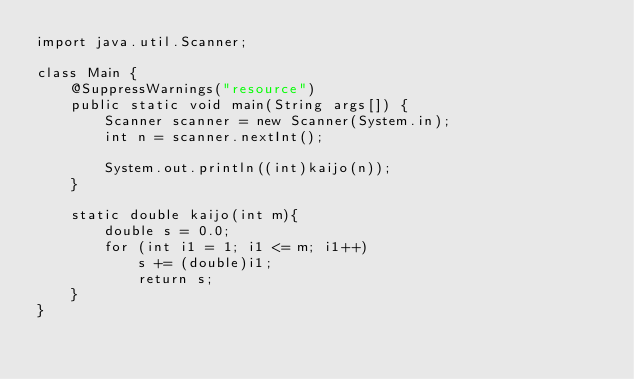<code> <loc_0><loc_0><loc_500><loc_500><_Java_>import java.util.Scanner;

class Main {
	@SuppressWarnings("resource")
	public static void main(String args[]) {
		Scanner scanner = new Scanner(System.in);
		int n = scanner.nextInt();
		
		System.out.println((int)kaijo(n));
	}

	static double kaijo(int m){
		double s = 0.0;
		for (int i1 = 1; i1 <= m; i1++)
			s += (double)i1;
			return s;
	}
}</code> 